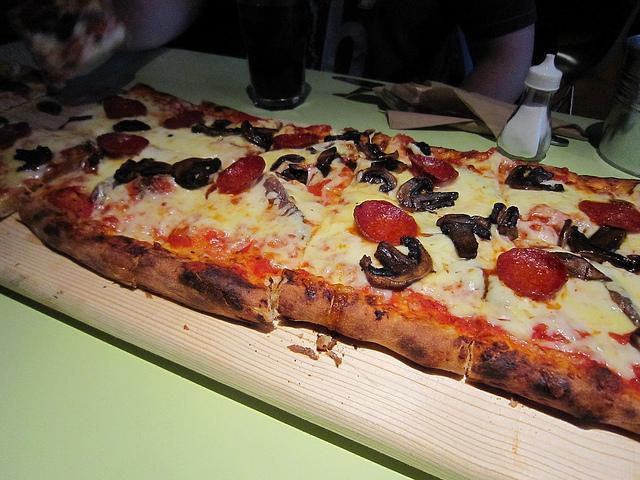What ingredient used as a veg toppings of the pizza?
Select the correct answer and articulate reasoning with the following format: 'Answer: answer
Rationale: rationale.'
Options: Celery, pasta, mushroom, capsicum. Answer: mushroom.
Rationale: There are many mushrooms. 